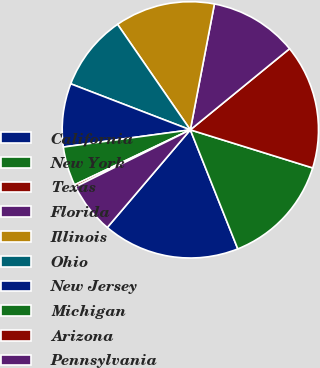Convert chart. <chart><loc_0><loc_0><loc_500><loc_500><pie_chart><fcel>California<fcel>New York<fcel>Texas<fcel>Florida<fcel>Illinois<fcel>Ohio<fcel>New Jersey<fcel>Michigan<fcel>Arizona<fcel>Pennsylvania<nl><fcel>17.25%<fcel>14.16%<fcel>15.71%<fcel>11.08%<fcel>12.62%<fcel>9.54%<fcel>7.99%<fcel>4.91%<fcel>0.28%<fcel>6.45%<nl></chart> 